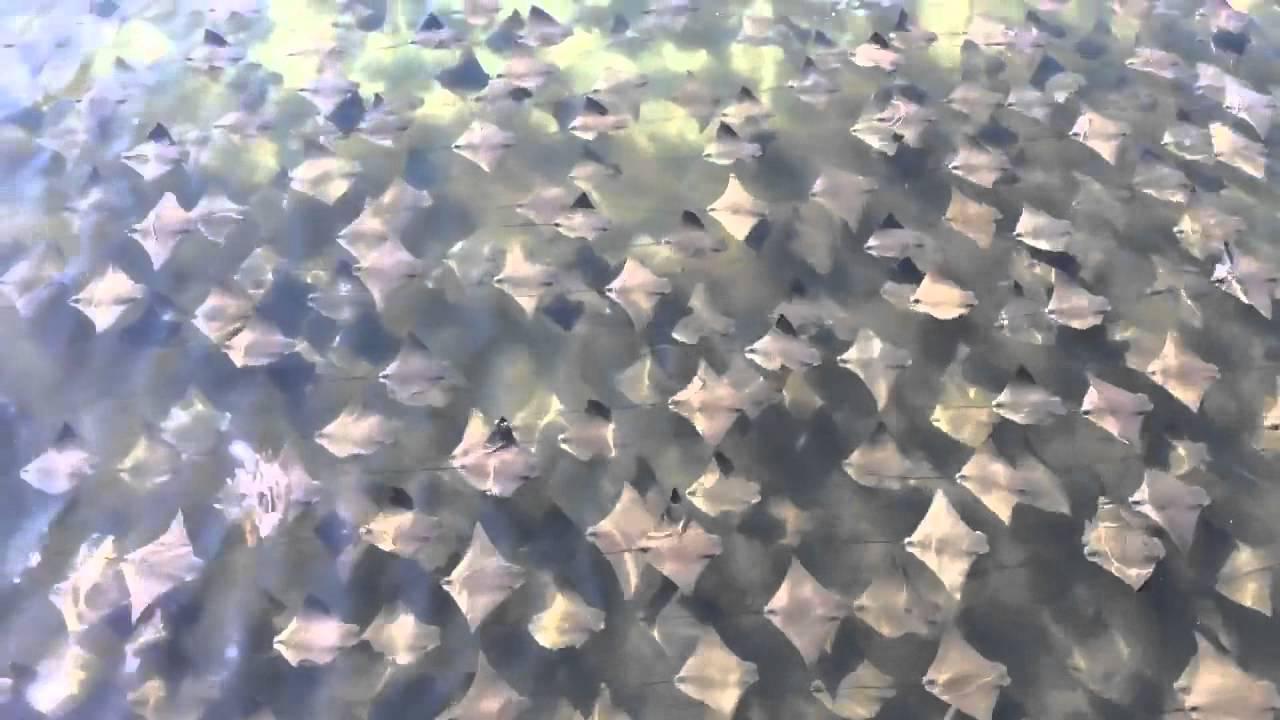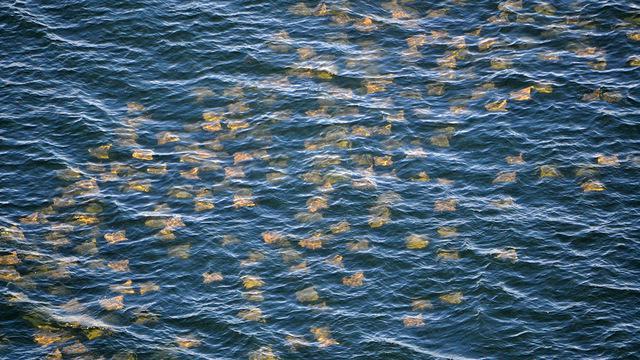The first image is the image on the left, the second image is the image on the right. Given the left and right images, does the statement "A single ray is shown in one of the images." hold true? Answer yes or no. No. 